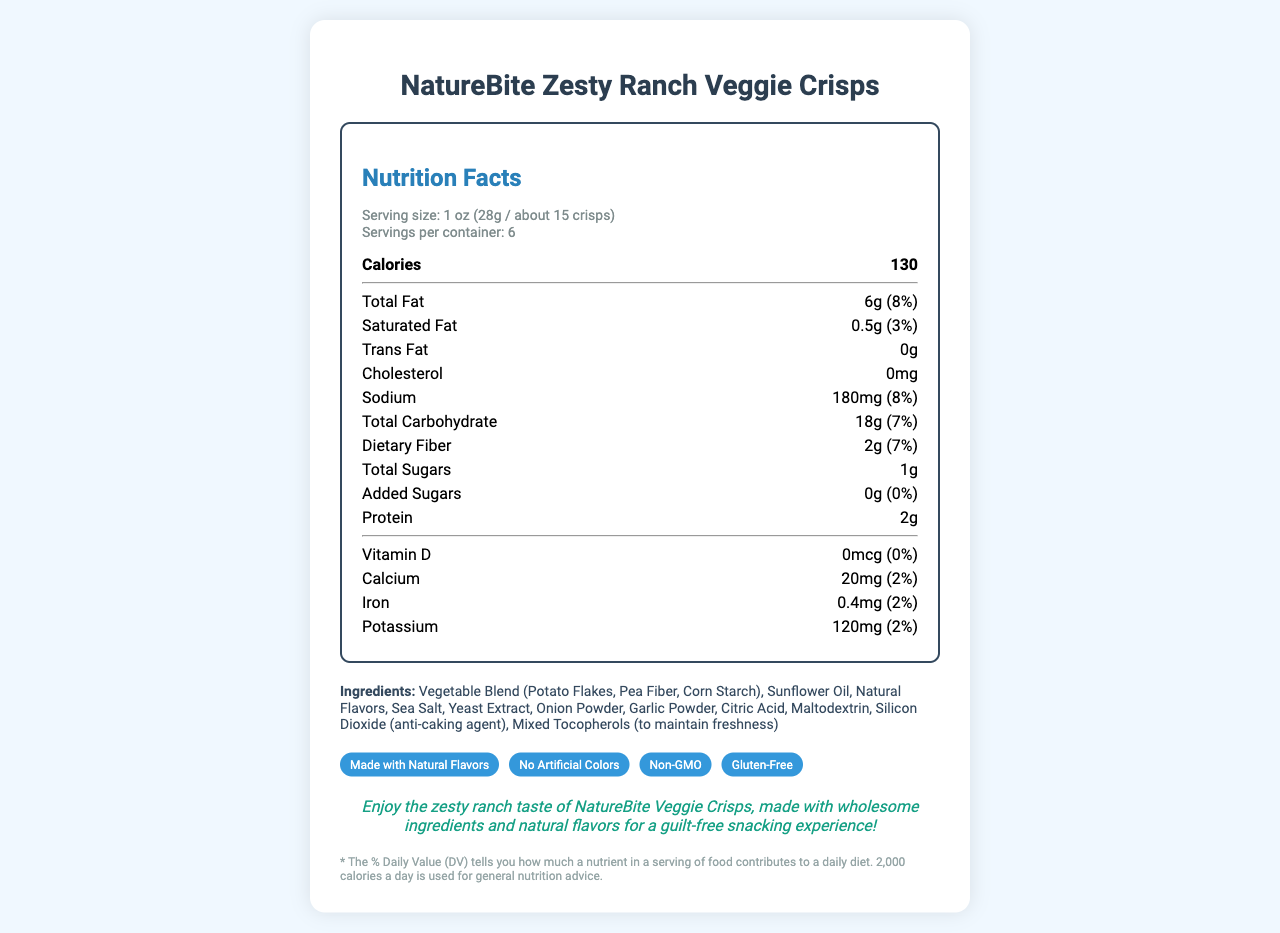what is the serving size? The serving size is explicitly stated in the serving information section of the nutrition facts label.
Answer: 1 oz (28g / about 15 crisps) how many calories are there per serving? The number of calories per serving is clearly listed in the bold section under calories.
Answer: 130 what percentage of daily value is the sodium content in one serving? The daily value percentage for sodium is mentioned next to its amount in the nutrient rows.
Answer: 8% how many grams of total fat does one serving contain? The total fat amount is provided in the nutrient rows where total fat is listed.
Answer: 6g are there any added sugars in the product? The document states that the amount of added sugars is 0g, which is 0% of the daily value.
Answer: No what are the main ingredients in NatureBite Zesty Ranch Veggie Crisps? The ingredients section lists all the components of the product.
Answer: Vegetable Blend (Potato Flakes, Pea Fiber, Corn Starch), Sunflower Oil, Natural Flavors, Sea Salt, Yeast Extract, Onion Powder, Garlic Powder, Citric Acid, Maltodextrin, Silicon Dioxide (anti-caking agent), Mixed Tocopherols (to maintain freshness) which claim is NOT true for NatureBite Zesty Ranch Veggie Crisps? A. Non-GMO B. Gluten-Free C. Organic D. No Artificial Colors The claims listed are "Made with Natural Flavors", "No Artificial Colors", "Non-GMO", "Gluten-Free". "Organic" is not among them.
Answer: C how many grams of protein are there in one serving? The protein amount is provided in the nutrient rows where protein is listed.
Answer: 2g was this product made in a gluten-free facility? The information provided states claims about the product being gluten-free, but not whether the processing facility is gluten-free.
Answer: Cannot be determined does this product contain any cholesterol? The document explicitly mentions that the cholesterol content is 0mg.
Answer: No list all the daily value percentages provided for vitamins and minerals The daily value percentages for vitamins and minerals are specified next to their amounts in the nutrient rows.
Answer: Vitamin D: 0%, Calcium: 2%, Iron: 2%, Potassium: 2% summarize the main idea of the document The document encompasses all nutritional aspects, ingredients, health claims, and some allergen information for the product to help consumers make informed choices.
Answer: NatureBite Zesty Ranch Veggie Crisps offers a breakdown of nutritional information, such as calories, fats, carbohydrates, and ingredients, highlighting natural flavors and making several health claims like being Non-GMO and Gluten-Free. do these crisps contain artificial colors? One of the claims highlighted in the document is "No Artificial Colors".
Answer: No 